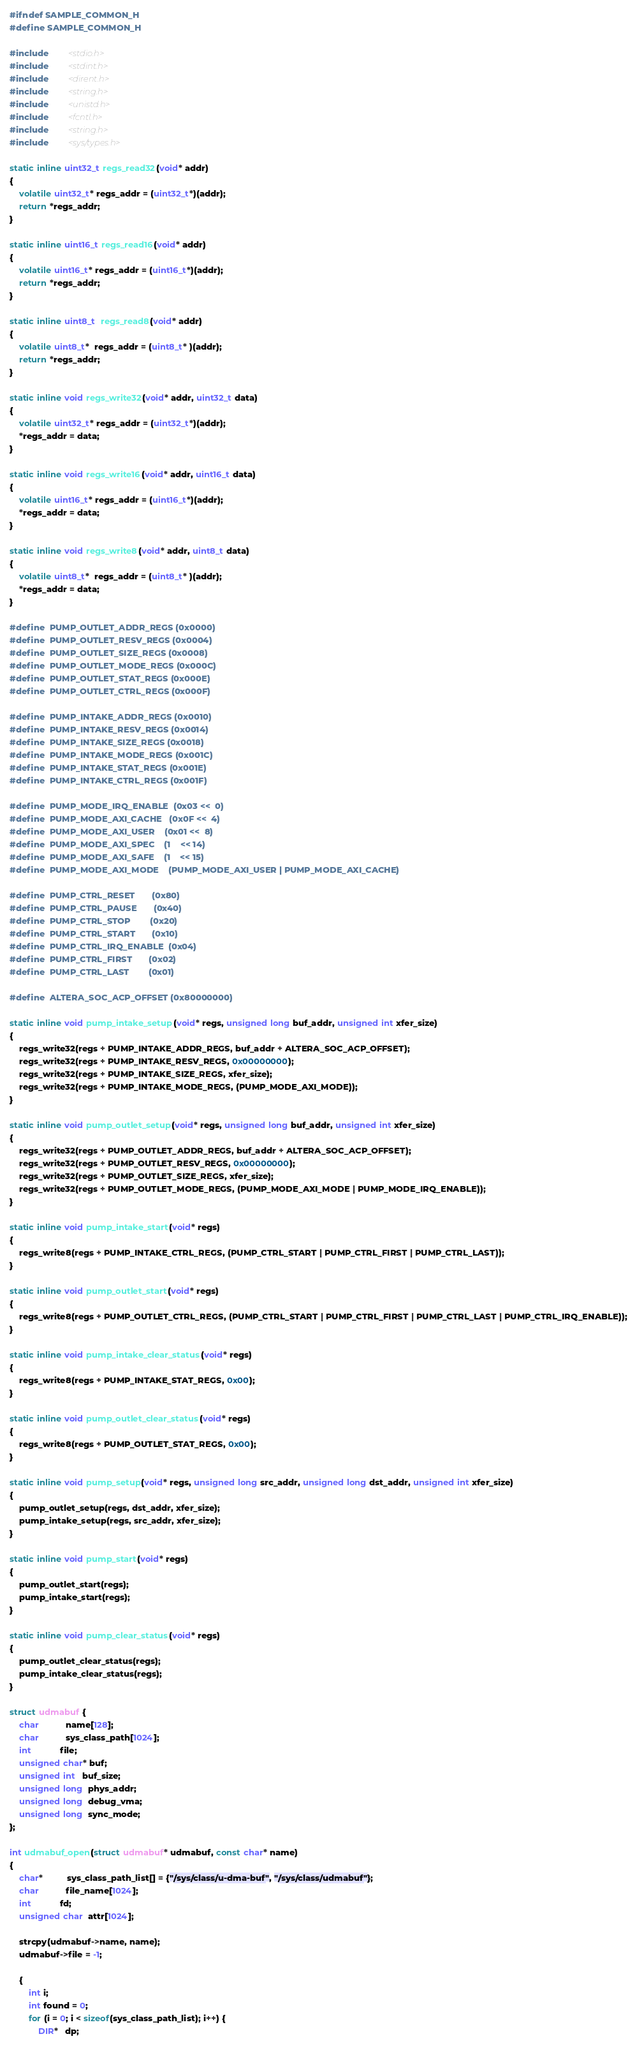<code> <loc_0><loc_0><loc_500><loc_500><_C_>#ifndef SAMPLE_COMMON_H
#define SAMPLE_COMMON_H

#include        <stdio.h>
#include        <stdint.h>
#include        <dirent.h>
#include        <string.h>
#include        <unistd.h>
#include        <fcntl.h>
#include        <string.h>
#include        <sys/types.h>

static inline uint32_t regs_read32(void* addr)
{
    volatile uint32_t* regs_addr = (uint32_t*)(addr);
    return *regs_addr;
}

static inline uint16_t regs_read16(void* addr)
{
    volatile uint16_t* regs_addr = (uint16_t*)(addr);
    return *regs_addr;
}

static inline uint8_t  regs_read8(void* addr)
{
    volatile uint8_t*  regs_addr = (uint8_t* )(addr);
    return *regs_addr;
}

static inline void regs_write32(void* addr, uint32_t data)
{
    volatile uint32_t* regs_addr = (uint32_t*)(addr);
    *regs_addr = data;
}

static inline void regs_write16(void* addr, uint16_t data)
{
    volatile uint16_t* regs_addr = (uint16_t*)(addr);
    *regs_addr = data;
}

static inline void regs_write8(void* addr, uint8_t data)
{
    volatile uint8_t*  regs_addr = (uint8_t* )(addr);
    *regs_addr = data;
}

#define  PUMP_OUTLET_ADDR_REGS (0x0000)
#define  PUMP_OUTLET_RESV_REGS (0x0004)
#define  PUMP_OUTLET_SIZE_REGS (0x0008)
#define  PUMP_OUTLET_MODE_REGS (0x000C)
#define  PUMP_OUTLET_STAT_REGS (0x000E)
#define  PUMP_OUTLET_CTRL_REGS (0x000F)

#define  PUMP_INTAKE_ADDR_REGS (0x0010)
#define  PUMP_INTAKE_RESV_REGS (0x0014)
#define  PUMP_INTAKE_SIZE_REGS (0x0018)
#define  PUMP_INTAKE_MODE_REGS (0x001C)
#define  PUMP_INTAKE_STAT_REGS (0x001E)
#define  PUMP_INTAKE_CTRL_REGS (0x001F)

#define  PUMP_MODE_IRQ_ENABLE  (0x03 <<  0)
#define  PUMP_MODE_AXI_CACHE   (0x0F <<  4)
#define  PUMP_MODE_AXI_USER    (0x01 <<  8)
#define  PUMP_MODE_AXI_SPEC    (1    << 14)
#define  PUMP_MODE_AXI_SAFE    (1    << 15)
#define  PUMP_MODE_AXI_MODE    (PUMP_MODE_AXI_USER | PUMP_MODE_AXI_CACHE)

#define  PUMP_CTRL_RESET       (0x80)
#define  PUMP_CTRL_PAUSE       (0x40)
#define  PUMP_CTRL_STOP        (0x20)
#define  PUMP_CTRL_START       (0x10)
#define  PUMP_CTRL_IRQ_ENABLE  (0x04)
#define  PUMP_CTRL_FIRST       (0x02)
#define  PUMP_CTRL_LAST        (0x01)

#define  ALTERA_SOC_ACP_OFFSET (0x80000000)

static inline void pump_intake_setup(void* regs, unsigned long buf_addr, unsigned int xfer_size)
{
    regs_write32(regs + PUMP_INTAKE_ADDR_REGS, buf_addr + ALTERA_SOC_ACP_OFFSET);
    regs_write32(regs + PUMP_INTAKE_RESV_REGS, 0x00000000);
    regs_write32(regs + PUMP_INTAKE_SIZE_REGS, xfer_size);
    regs_write32(regs + PUMP_INTAKE_MODE_REGS, (PUMP_MODE_AXI_MODE));
}

static inline void pump_outlet_setup(void* regs, unsigned long buf_addr, unsigned int xfer_size)
{
    regs_write32(regs + PUMP_OUTLET_ADDR_REGS, buf_addr + ALTERA_SOC_ACP_OFFSET);
    regs_write32(regs + PUMP_OUTLET_RESV_REGS, 0x00000000);
    regs_write32(regs + PUMP_OUTLET_SIZE_REGS, xfer_size);
    regs_write32(regs + PUMP_OUTLET_MODE_REGS, (PUMP_MODE_AXI_MODE | PUMP_MODE_IRQ_ENABLE));
}

static inline void pump_intake_start(void* regs)
{
    regs_write8(regs + PUMP_INTAKE_CTRL_REGS, (PUMP_CTRL_START | PUMP_CTRL_FIRST | PUMP_CTRL_LAST));
}

static inline void pump_outlet_start(void* regs)
{
    regs_write8(regs + PUMP_OUTLET_CTRL_REGS, (PUMP_CTRL_START | PUMP_CTRL_FIRST | PUMP_CTRL_LAST | PUMP_CTRL_IRQ_ENABLE));
}

static inline void pump_intake_clear_status(void* regs)
{
    regs_write8(regs + PUMP_INTAKE_STAT_REGS, 0x00);
}

static inline void pump_outlet_clear_status(void* regs)
{
    regs_write8(regs + PUMP_OUTLET_STAT_REGS, 0x00);
}

static inline void pump_setup(void* regs, unsigned long src_addr, unsigned long dst_addr, unsigned int xfer_size)
{
    pump_outlet_setup(regs, dst_addr, xfer_size);
    pump_intake_setup(regs, src_addr, xfer_size);
}

static inline void pump_start(void* regs)
{
    pump_outlet_start(regs);
    pump_intake_start(regs);
}

static inline void pump_clear_status(void* regs)
{
    pump_outlet_clear_status(regs);
    pump_intake_clear_status(regs);
}

struct udmabuf {
    char           name[128];
    char           sys_class_path[1024];
    int            file;
    unsigned char* buf;
    unsigned int   buf_size;
    unsigned long  phys_addr;
    unsigned long  debug_vma;
    unsigned long  sync_mode;
};

int udmabuf_open(struct udmabuf* udmabuf, const char* name)
{
    char*          sys_class_path_list[] = {"/sys/class/u-dma-buf", "/sys/class/udmabuf"};
    char           file_name[1024];
    int            fd;
    unsigned char  attr[1024];

    strcpy(udmabuf->name, name);
    udmabuf->file = -1;

    {
        int i;
        int found = 0;
        for (i = 0; i < sizeof(sys_class_path_list); i++) {
            DIR*   dp;</code> 